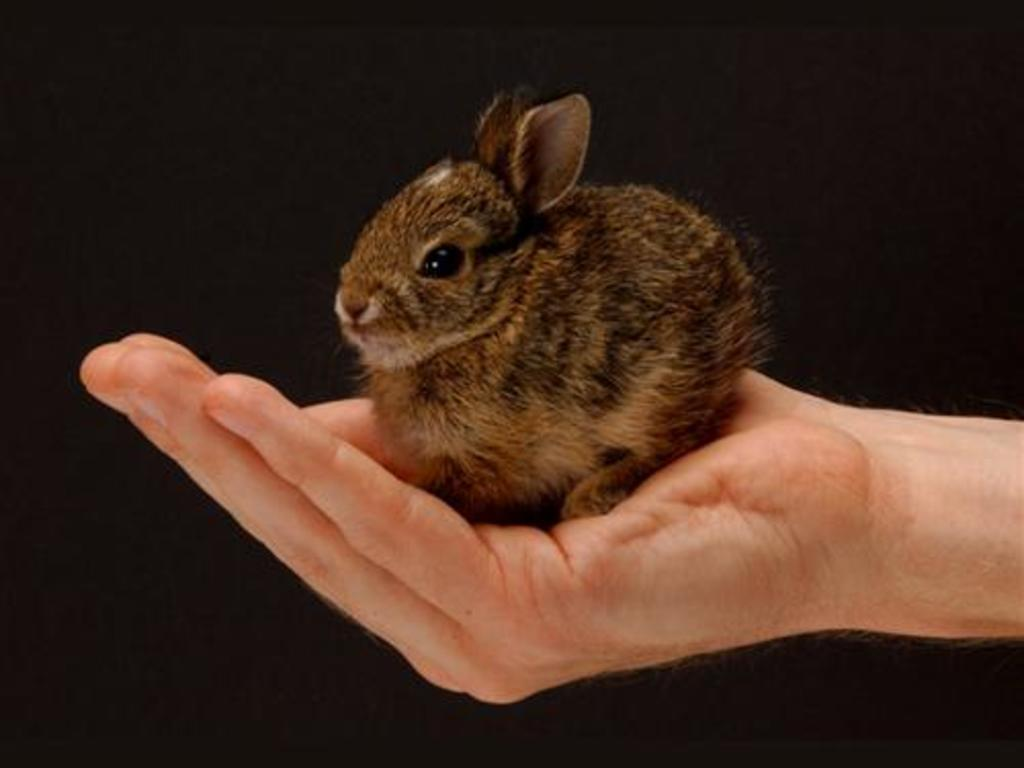What animal is present in the image? There is a rabbit in the image. Where is the rabbit located? The rabbit is on a hand. What type of cream is being applied to the rabbit's head in the image? There is no cream being applied to the rabbit's head in the image, as the provided facts do not mention any cream or head-related activities. 